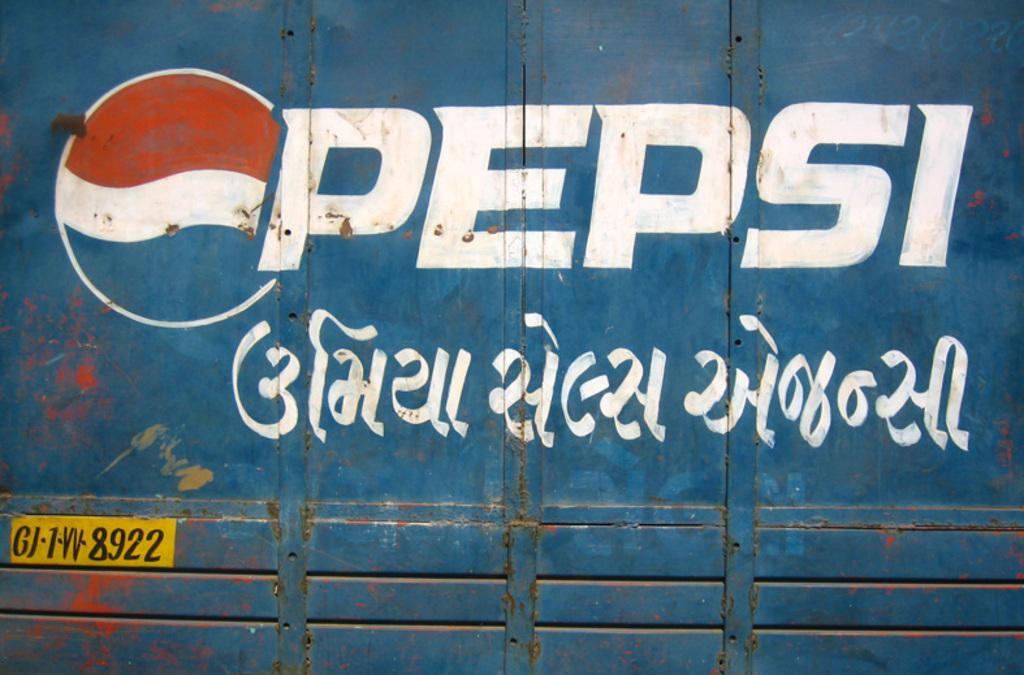Provide a one-sentence caption for the provided image. A sign of Pepsi with some other language in writing. 